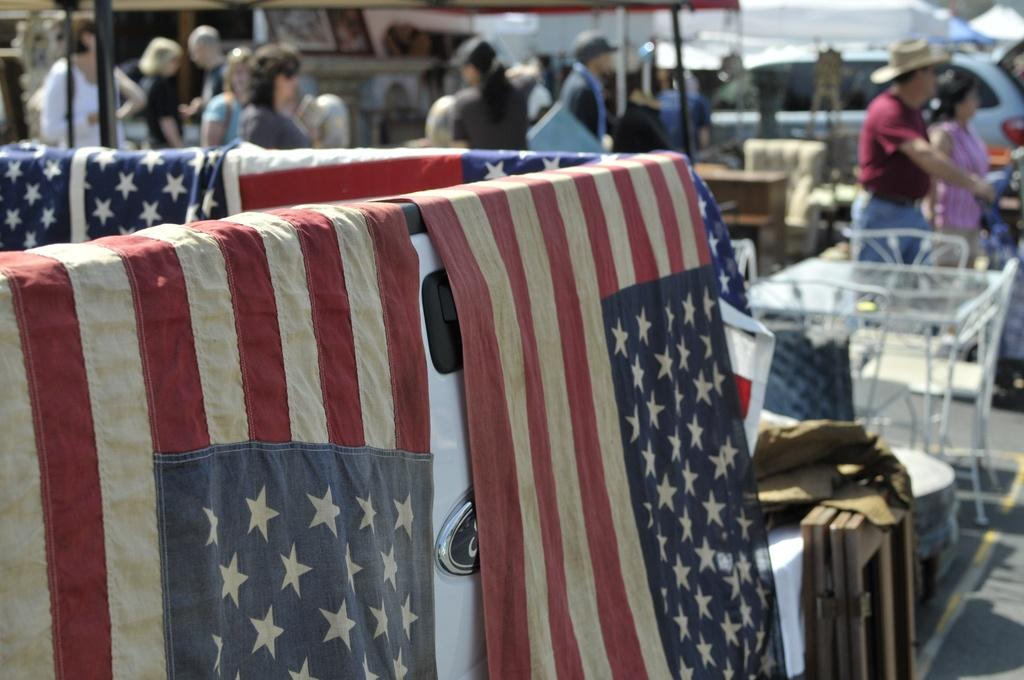What type of furniture is present in the image? There are chairs and tables in the image. What else can be seen in the image besides furniture? There are vehicles, people, and flags in the image. Where are the flags located in the image? The flags are on a white and black color object. How would you describe the background of the image? The background of the image is blurred. Where is the faucet located in the image? There is no faucet present in the image. What type of hook is used to hang the flags in the image? There is no hook visible in the image; the flags are on a white and black color object. 